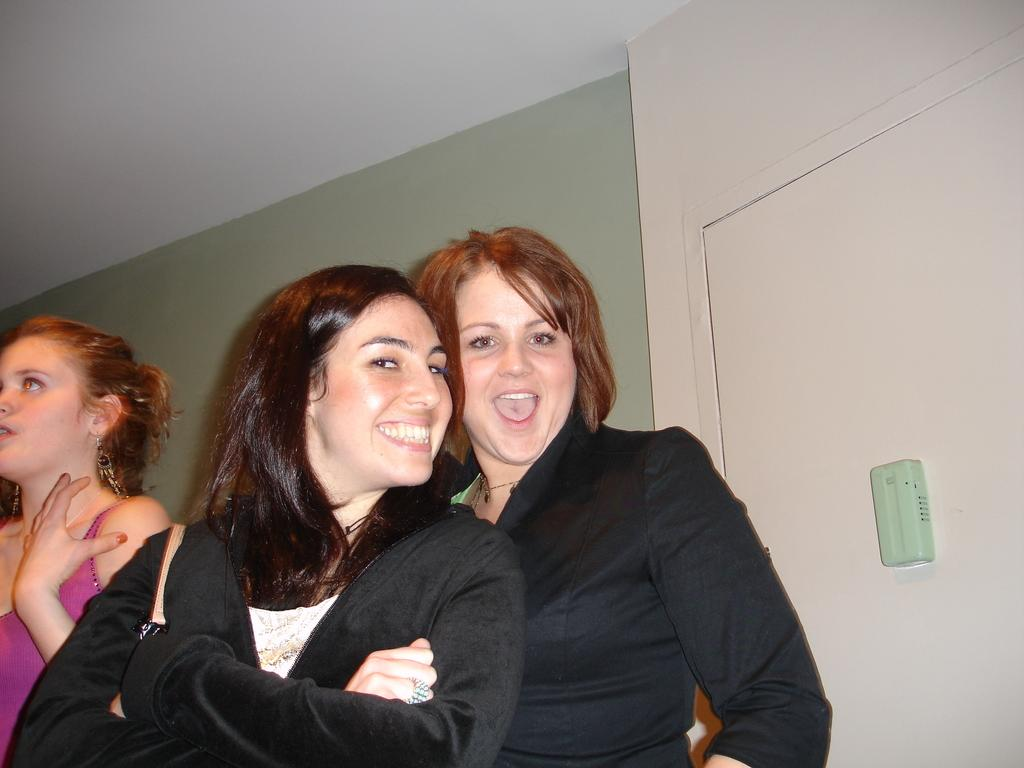How many women are in the image? There are two women in the image. What are the expressions on the women's faces? The women are smiling. What is the color and material of the object on the white surface? The object is green, and it is on a white surface. Can you describe the person visible on the left side of the image? A person is visible on the left side of the image, but their features are not clear enough to provide a detailed description. What can be seen in the background of the image? A wall is visible in the background of the image. What subject are the women teaching in the image? There is no indication in the image that the women are teaching any subject. What type of prison can be seen in the background of the image? There is no prison visible in the background of the image; it features a wall instead. 